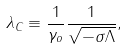Convert formula to latex. <formula><loc_0><loc_0><loc_500><loc_500>\lambda _ { C } \equiv \frac { 1 } { \gamma _ { o } } \frac { 1 } { \sqrt { - \sigma \Lambda } } ,</formula> 